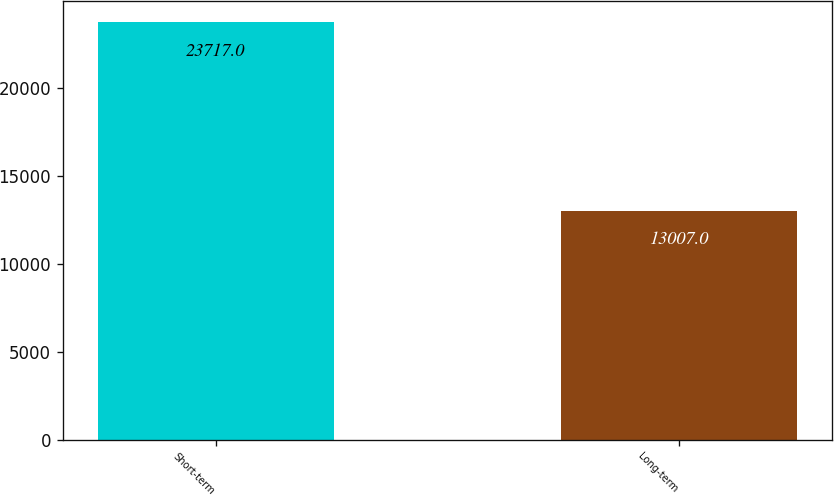Convert chart to OTSL. <chart><loc_0><loc_0><loc_500><loc_500><bar_chart><fcel>Short-term<fcel>Long-term<nl><fcel>23717<fcel>13007<nl></chart> 